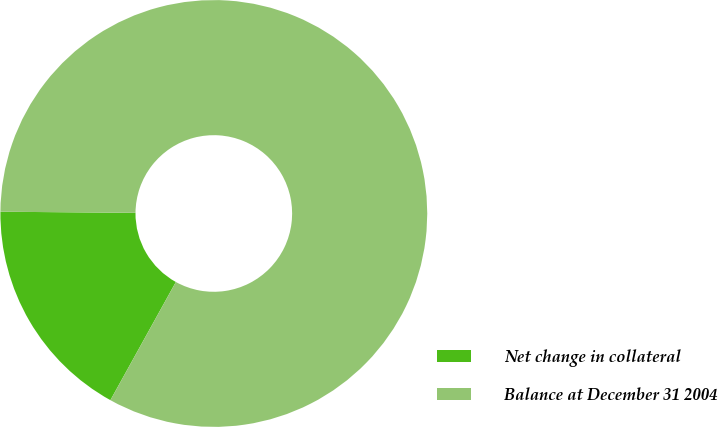Convert chart. <chart><loc_0><loc_0><loc_500><loc_500><pie_chart><fcel>Net change in collateral<fcel>Balance at December 31 2004<nl><fcel>17.08%<fcel>82.92%<nl></chart> 